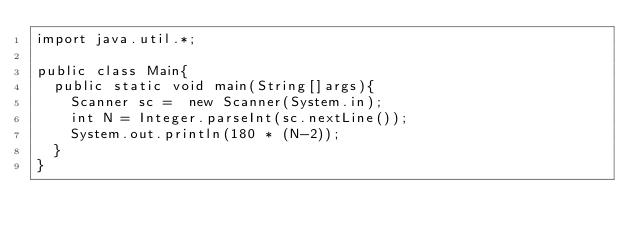Convert code to text. <code><loc_0><loc_0><loc_500><loc_500><_Java_>import java.util.*;
 
public class Main{
  public static void main(String[]args){
    Scanner sc =  new Scanner(System.in);
    int N = Integer.parseInt(sc.nextLine());
    System.out.println(180 * (N-2));
  }
}</code> 